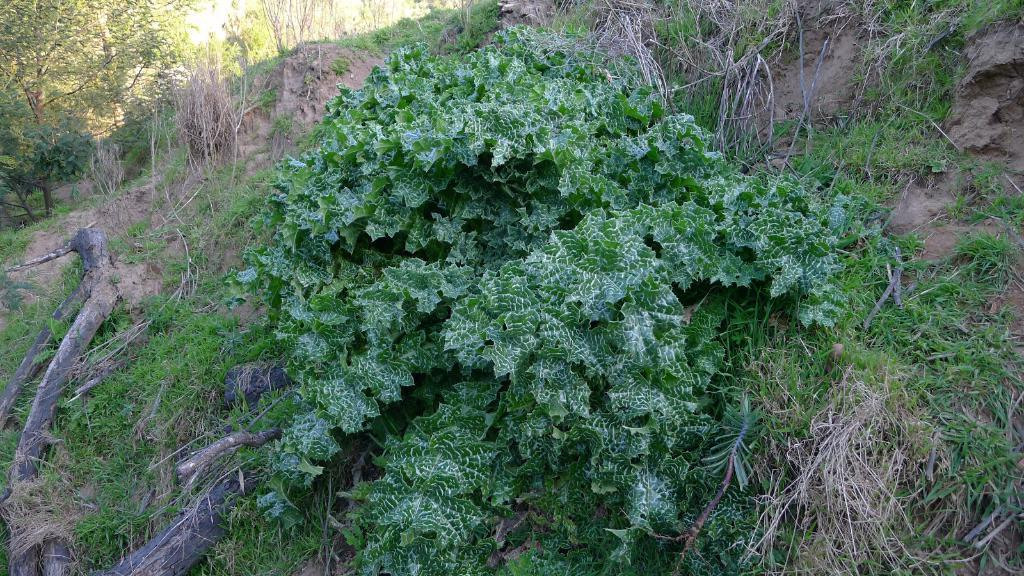What type of environment is depicted in the image? The image features greenery, suggesting a natural or outdoor setting. What type of skin condition can be seen on the leaves in the image? There is no skin condition present on the leaves in the image, as leaves are part of plants and do not have skin. 